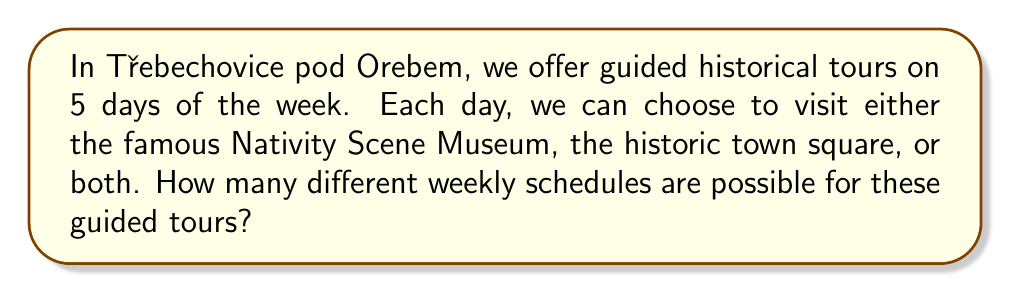Help me with this question. Let's approach this step-by-step:

1) For each day, we have 3 options:
   - Visit only the Nativity Scene Museum
   - Visit only the historic town square
   - Visit both

2) This means for each day, we have 3 choices.

3) We need to make this choice for 5 days of the week.

4) This is a perfect scenario for using the multiplication principle of counting.

5) The multiplication principle states that if we have a sequence of $n$ choices, where the $i$-th choice has $k_i$ options, then the total number of possible outcomes is the product of all $k_i$.

6) In our case, we have 5 choices (one for each day), and each choice has 3 options.

7) Therefore, the total number of possible schedules is:

   $$ 3 \times 3 \times 3 \times 3 \times 3 = 3^5 $$

8) Calculate:
   $$ 3^5 = 3 \times 3 \times 3 \times 3 \times 3 = 243 $$

Thus, there are 243 different possible weekly schedules for the guided tours.
Answer: $243$ 